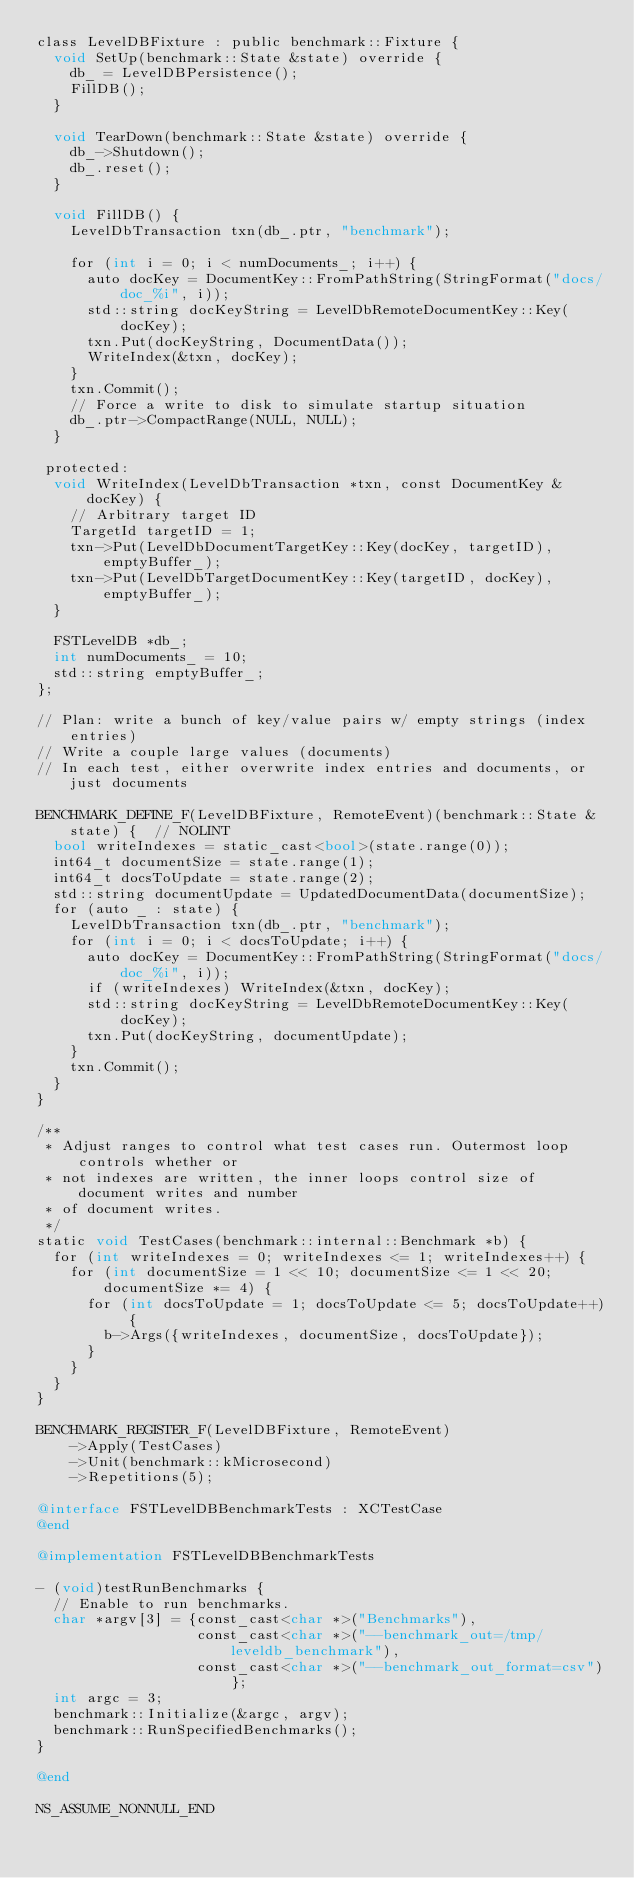Convert code to text. <code><loc_0><loc_0><loc_500><loc_500><_ObjectiveC_>class LevelDBFixture : public benchmark::Fixture {
  void SetUp(benchmark::State &state) override {
    db_ = LevelDBPersistence();
    FillDB();
  }

  void TearDown(benchmark::State &state) override {
    db_->Shutdown();
    db_.reset();
  }

  void FillDB() {
    LevelDbTransaction txn(db_.ptr, "benchmark");

    for (int i = 0; i < numDocuments_; i++) {
      auto docKey = DocumentKey::FromPathString(StringFormat("docs/doc_%i", i));
      std::string docKeyString = LevelDbRemoteDocumentKey::Key(docKey);
      txn.Put(docKeyString, DocumentData());
      WriteIndex(&txn, docKey);
    }
    txn.Commit();
    // Force a write to disk to simulate startup situation
    db_.ptr->CompactRange(NULL, NULL);
  }

 protected:
  void WriteIndex(LevelDbTransaction *txn, const DocumentKey &docKey) {
    // Arbitrary target ID
    TargetId targetID = 1;
    txn->Put(LevelDbDocumentTargetKey::Key(docKey, targetID), emptyBuffer_);
    txn->Put(LevelDbTargetDocumentKey::Key(targetID, docKey), emptyBuffer_);
  }

  FSTLevelDB *db_;
  int numDocuments_ = 10;
  std::string emptyBuffer_;
};

// Plan: write a bunch of key/value pairs w/ empty strings (index entries)
// Write a couple large values (documents)
// In each test, either overwrite index entries and documents, or just documents

BENCHMARK_DEFINE_F(LevelDBFixture, RemoteEvent)(benchmark::State &state) {  // NOLINT
  bool writeIndexes = static_cast<bool>(state.range(0));
  int64_t documentSize = state.range(1);
  int64_t docsToUpdate = state.range(2);
  std::string documentUpdate = UpdatedDocumentData(documentSize);
  for (auto _ : state) {
    LevelDbTransaction txn(db_.ptr, "benchmark");
    for (int i = 0; i < docsToUpdate; i++) {
      auto docKey = DocumentKey::FromPathString(StringFormat("docs/doc_%i", i));
      if (writeIndexes) WriteIndex(&txn, docKey);
      std::string docKeyString = LevelDbRemoteDocumentKey::Key(docKey);
      txn.Put(docKeyString, documentUpdate);
    }
    txn.Commit();
  }
}

/**
 * Adjust ranges to control what test cases run. Outermost loop controls whether or
 * not indexes are written, the inner loops control size of document writes and number
 * of document writes.
 */
static void TestCases(benchmark::internal::Benchmark *b) {
  for (int writeIndexes = 0; writeIndexes <= 1; writeIndexes++) {
    for (int documentSize = 1 << 10; documentSize <= 1 << 20; documentSize *= 4) {
      for (int docsToUpdate = 1; docsToUpdate <= 5; docsToUpdate++) {
        b->Args({writeIndexes, documentSize, docsToUpdate});
      }
    }
  }
}

BENCHMARK_REGISTER_F(LevelDBFixture, RemoteEvent)
    ->Apply(TestCases)
    ->Unit(benchmark::kMicrosecond)
    ->Repetitions(5);

@interface FSTLevelDBBenchmarkTests : XCTestCase
@end

@implementation FSTLevelDBBenchmarkTests

- (void)testRunBenchmarks {
  // Enable to run benchmarks.
  char *argv[3] = {const_cast<char *>("Benchmarks"),
                   const_cast<char *>("--benchmark_out=/tmp/leveldb_benchmark"),
                   const_cast<char *>("--benchmark_out_format=csv")};
  int argc = 3;
  benchmark::Initialize(&argc, argv);
  benchmark::RunSpecifiedBenchmarks();
}

@end

NS_ASSUME_NONNULL_END
</code> 